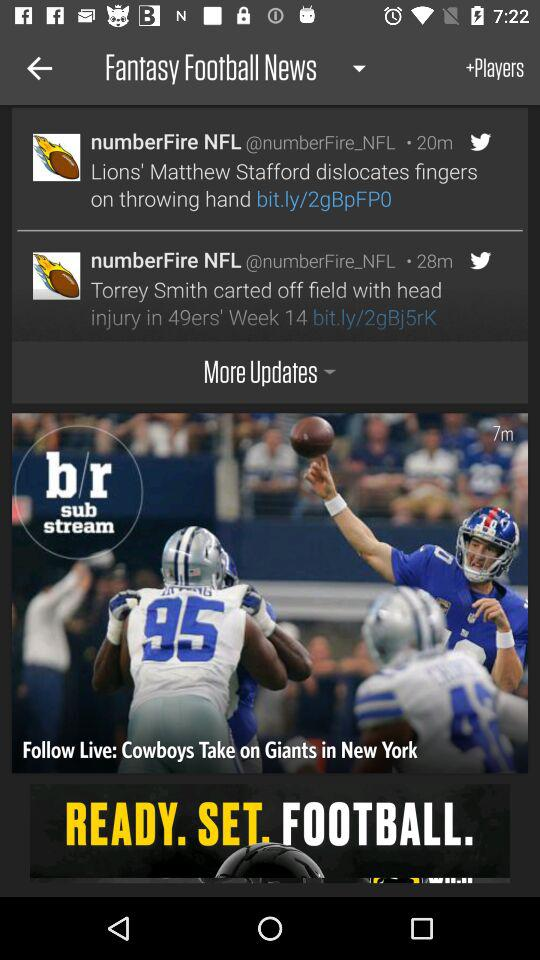How many news items are there?
Answer the question using a single word or phrase. 2 